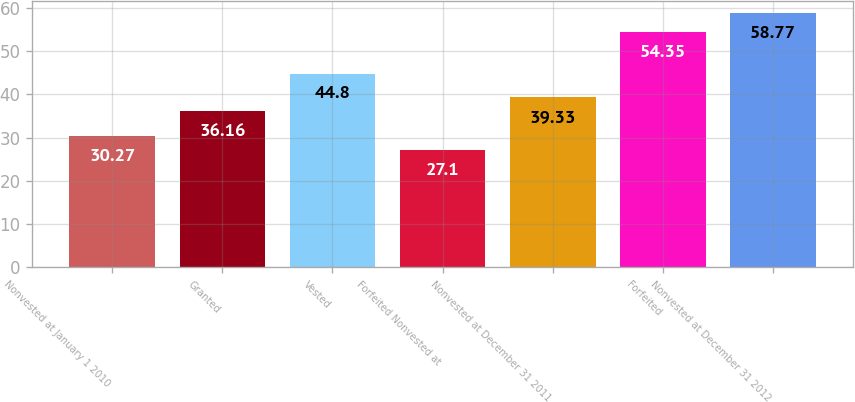<chart> <loc_0><loc_0><loc_500><loc_500><bar_chart><fcel>Nonvested at January 1 2010<fcel>Granted<fcel>Vested<fcel>Forfeited Nonvested at<fcel>Nonvested at December 31 2011<fcel>Forfeited<fcel>Nonvested at December 31 2012<nl><fcel>30.27<fcel>36.16<fcel>44.8<fcel>27.1<fcel>39.33<fcel>54.35<fcel>58.77<nl></chart> 